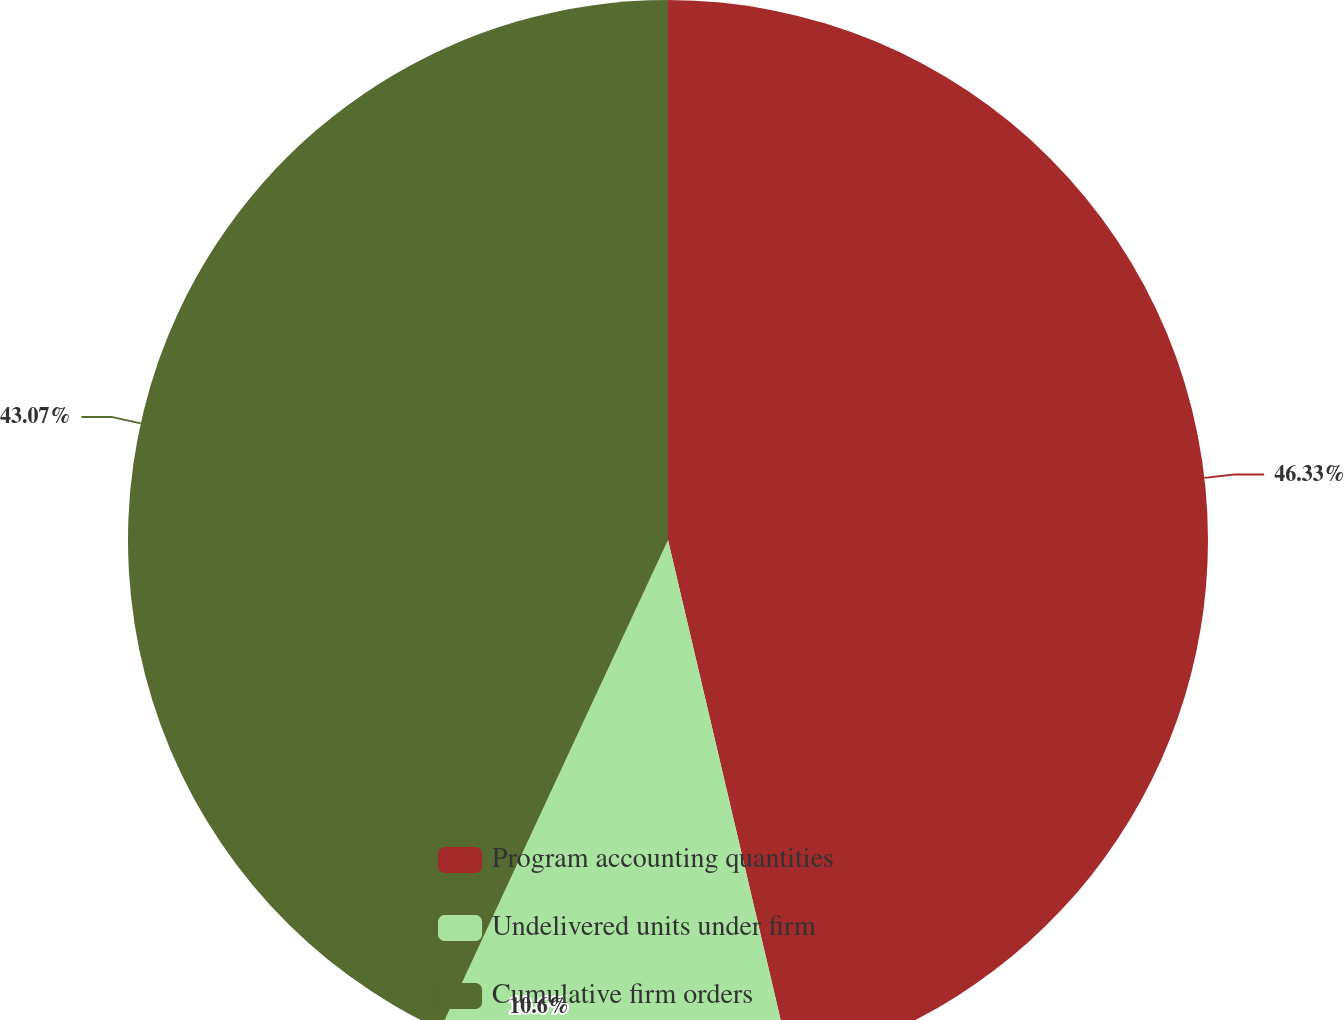<chart> <loc_0><loc_0><loc_500><loc_500><pie_chart><fcel>Program accounting quantities<fcel>Undelivered units under firm<fcel>Cumulative firm orders<nl><fcel>46.33%<fcel>10.6%<fcel>43.07%<nl></chart> 